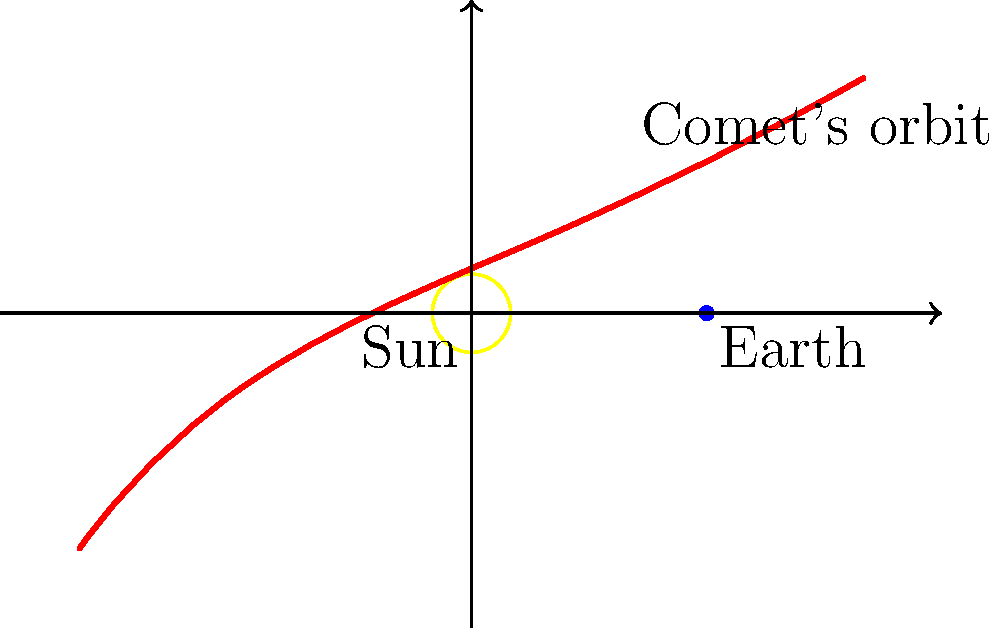As a radio host promoting Cut Out Cancer events, you often use interesting facts to engage your audience. In discussing the similarities between the unpredictability of life and celestial events, you want to explain comet visibility. What determines whether a comet will be visible from Earth, and how does this relate to its orbit around the Sun? To understand comet visibility from Earth, let's break it down step-by-step:

1. Comet orbits: Comets typically have highly elliptical orbits around the Sun. The orbit shown in the diagram is a simplified representation.

2. Perihelion and aphelion: The point of a comet's orbit closest to the Sun is called perihelion, while the farthest point is aphelion.

3. Comet activity: As comets approach the Sun (perihelion), they become more active due to solar radiation. This causes ice to sublimate, creating a coma (atmosphere) and often a tail.

4. Visibility factors:
   a) Distance from Earth: The comet must be close enough to Earth to be seen.
   b) Size and brightness: Larger, more active comets are easier to spot.
   c) Position relative to the Sun: Comets are most visible when they're close to the Sun but not lost in its glare.

5. Orbital period: Some comets have short orbital periods (< 200 years), while others have very long periods (> 200 years).

6. Unpredictability: Like cancer, comets can appear unexpectedly, especially long-period comets that may only be visible once in a lifetime.

The visibility of a comet from Earth depends on its proximity to both the Sun and Earth, its size and activity level, and its position in the night sky. This unpredictability and rarity can be likened to life's challenges, including health issues like cancer, emphasizing the importance of awareness and preparedness promoted by Cut Out Cancer events.
Answer: Proximity to Sun and Earth, comet size, activity level, and sky position 